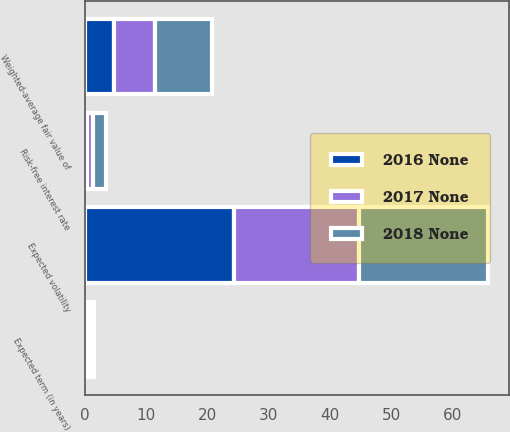Convert chart to OTSL. <chart><loc_0><loc_0><loc_500><loc_500><stacked_bar_chart><ecel><fcel>Expected volatility<fcel>Risk-free interest rate<fcel>Expected term (in years)<fcel>Weighted-average fair value of<nl><fcel>2018 None<fcel>21.1<fcel>2.05<fcel>0.5<fcel>9.24<nl><fcel>2017 None<fcel>20.4<fcel>0.92<fcel>0.5<fcel>6.64<nl><fcel>2016 None<fcel>24.4<fcel>0.43<fcel>0.5<fcel>4.85<nl></chart> 